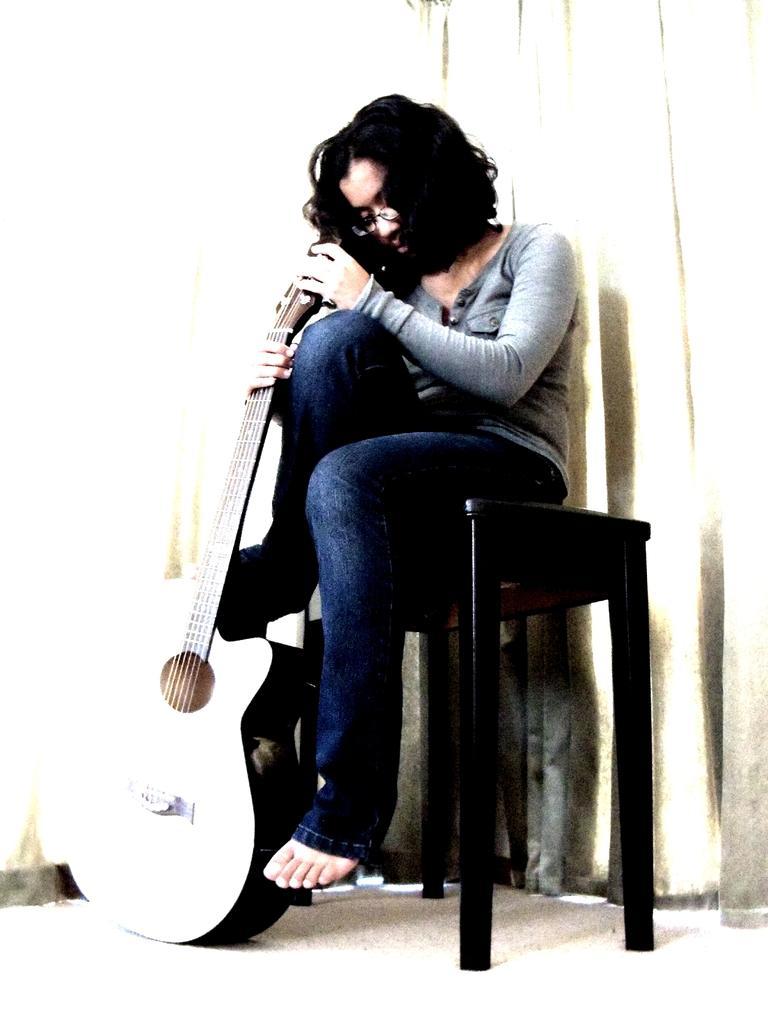Could you give a brief overview of what you see in this image? There is a woman sitting on a table holding a guitar. 